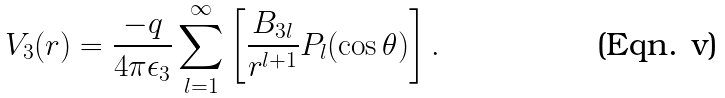Convert formula to latex. <formula><loc_0><loc_0><loc_500><loc_500>V _ { 3 } ( r ) = \frac { - q } { 4 \pi \epsilon _ { 3 } } \sum _ { l = 1 } ^ { \infty } \left [ \frac { B _ { 3 l } } { r ^ { l + 1 } } P _ { l } ( \cos \theta ) \right ] .</formula> 